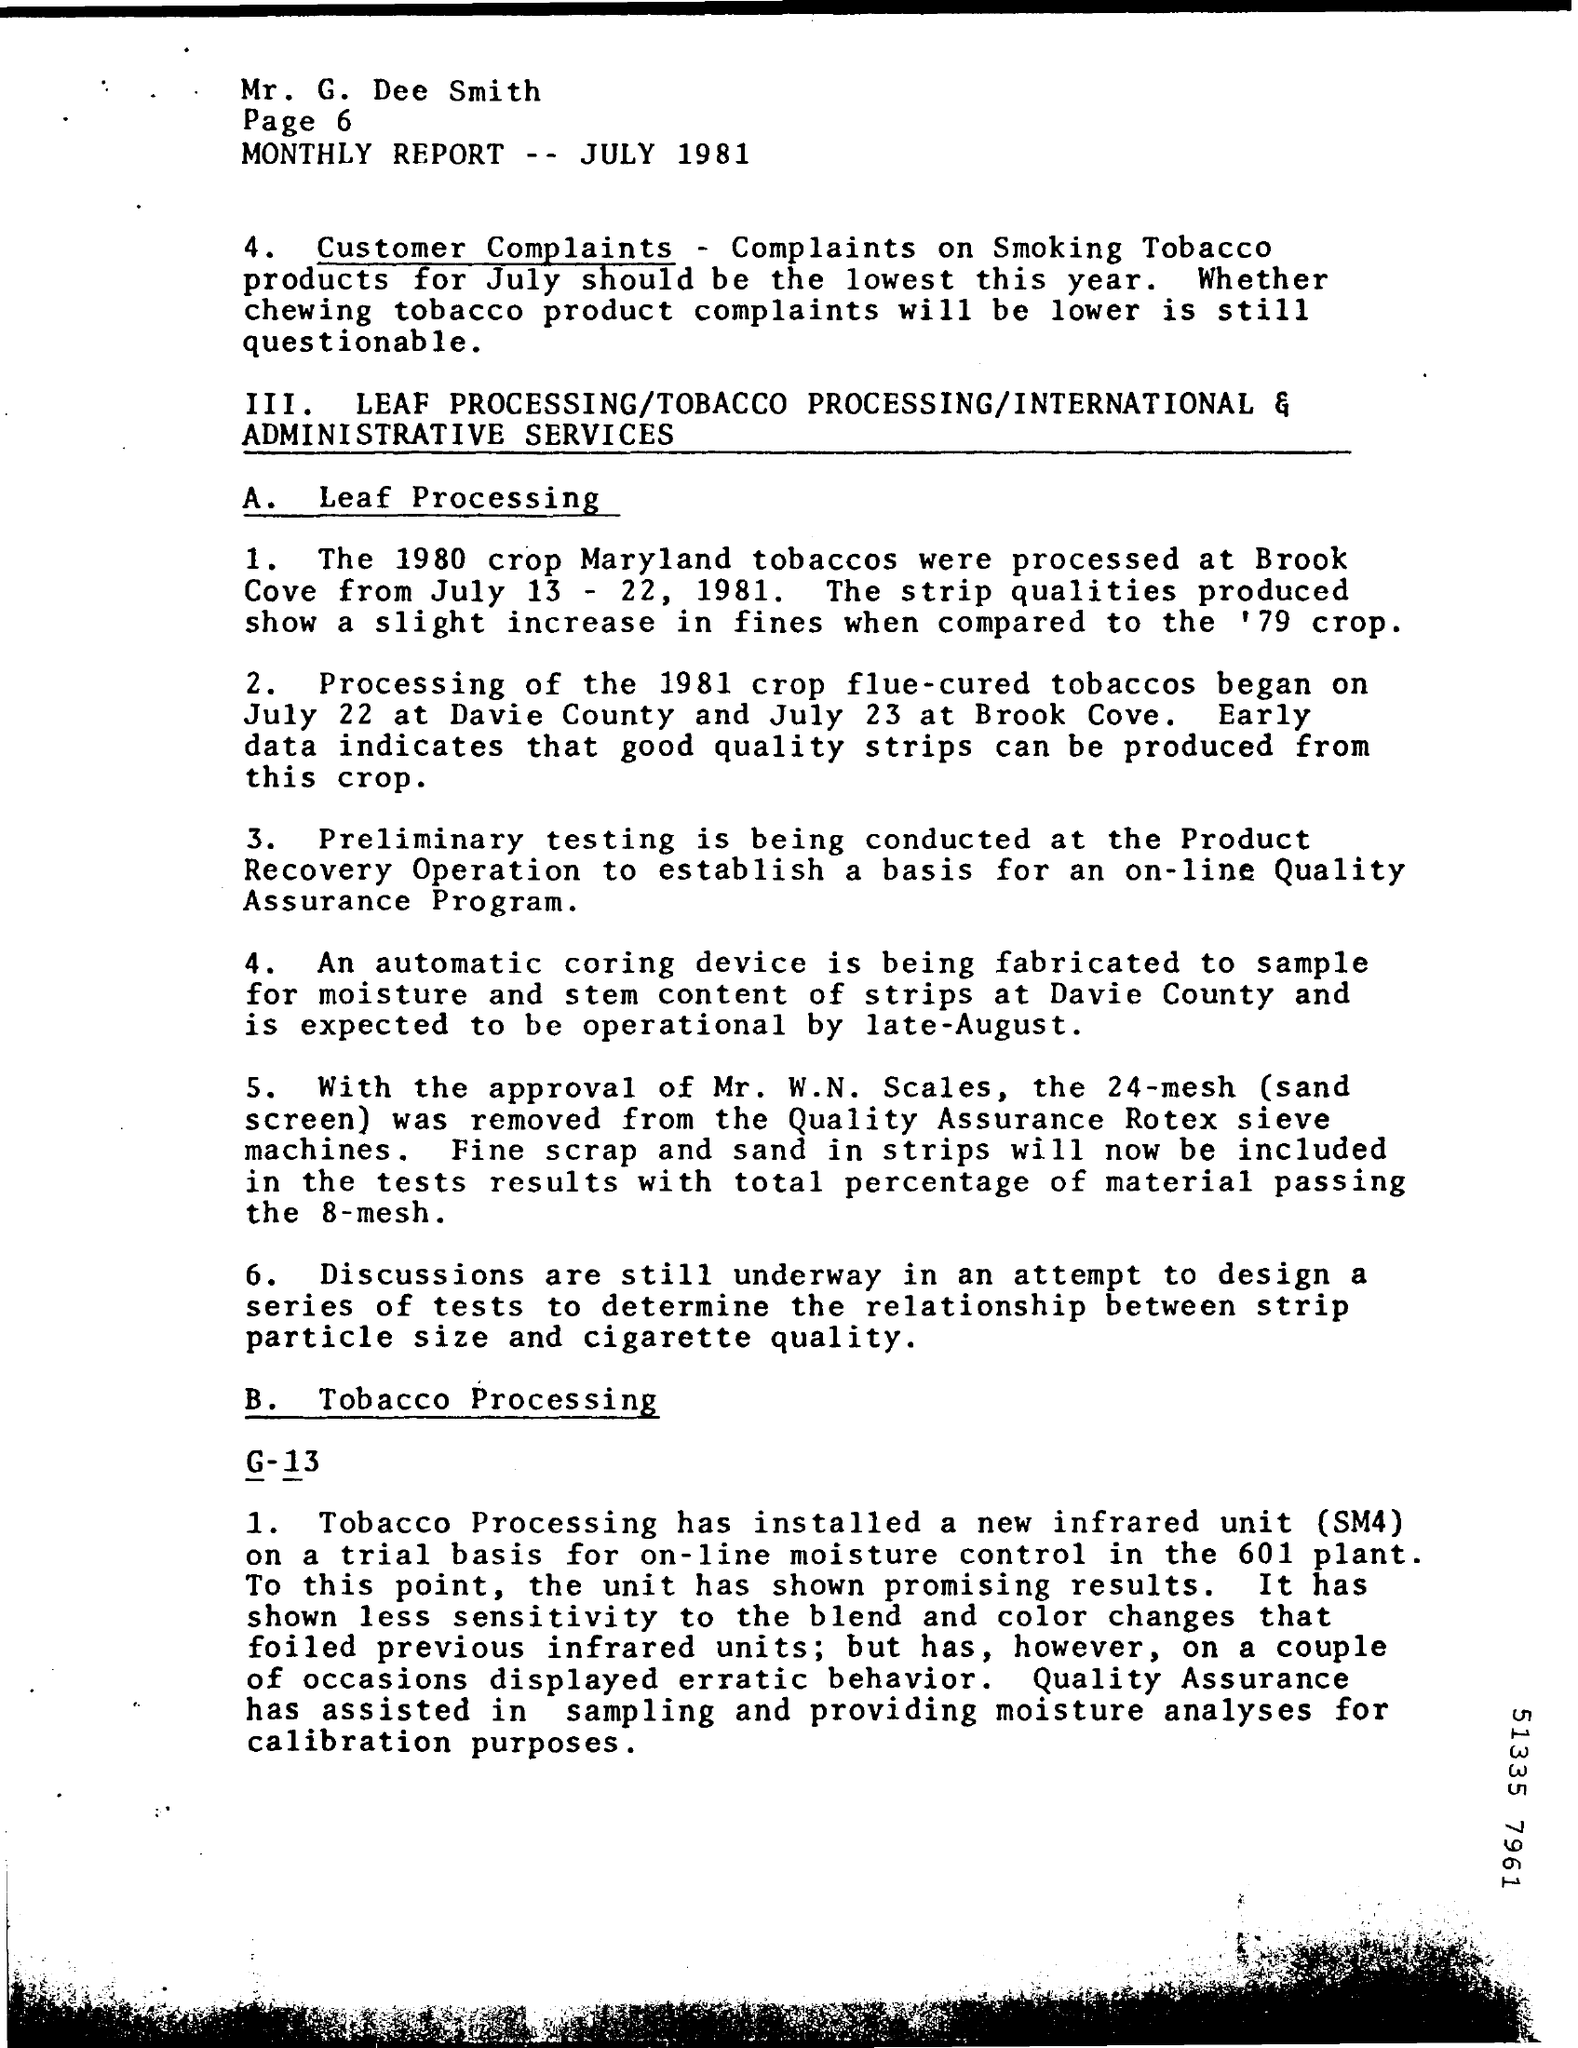Where were the 1980 crop Maryland tobaccos processed?
Your response must be concise. At brook cove. What device is being fabricated to sample for moisture and stem content of strips?
Keep it short and to the point. Automatic coring device. 